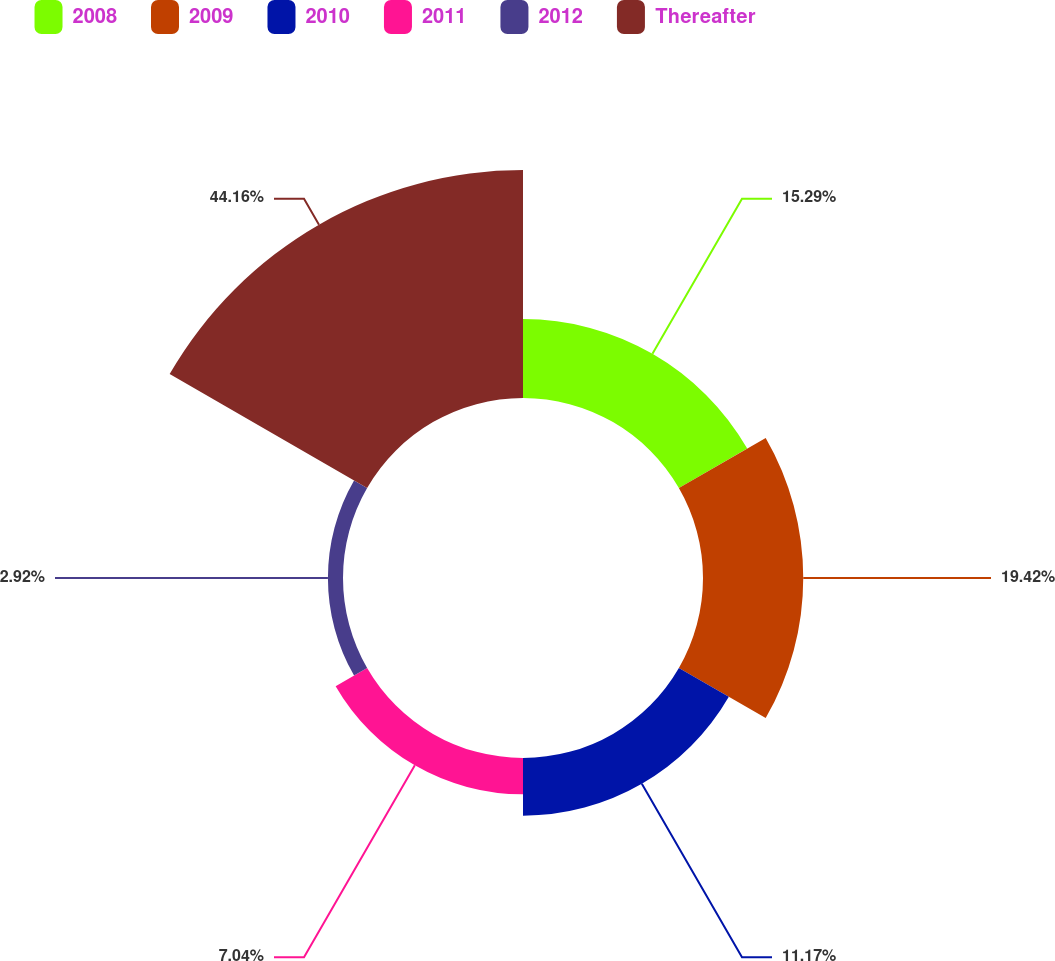Convert chart. <chart><loc_0><loc_0><loc_500><loc_500><pie_chart><fcel>2008<fcel>2009<fcel>2010<fcel>2011<fcel>2012<fcel>Thereafter<nl><fcel>15.29%<fcel>19.42%<fcel>11.17%<fcel>7.04%<fcel>2.92%<fcel>44.17%<nl></chart> 